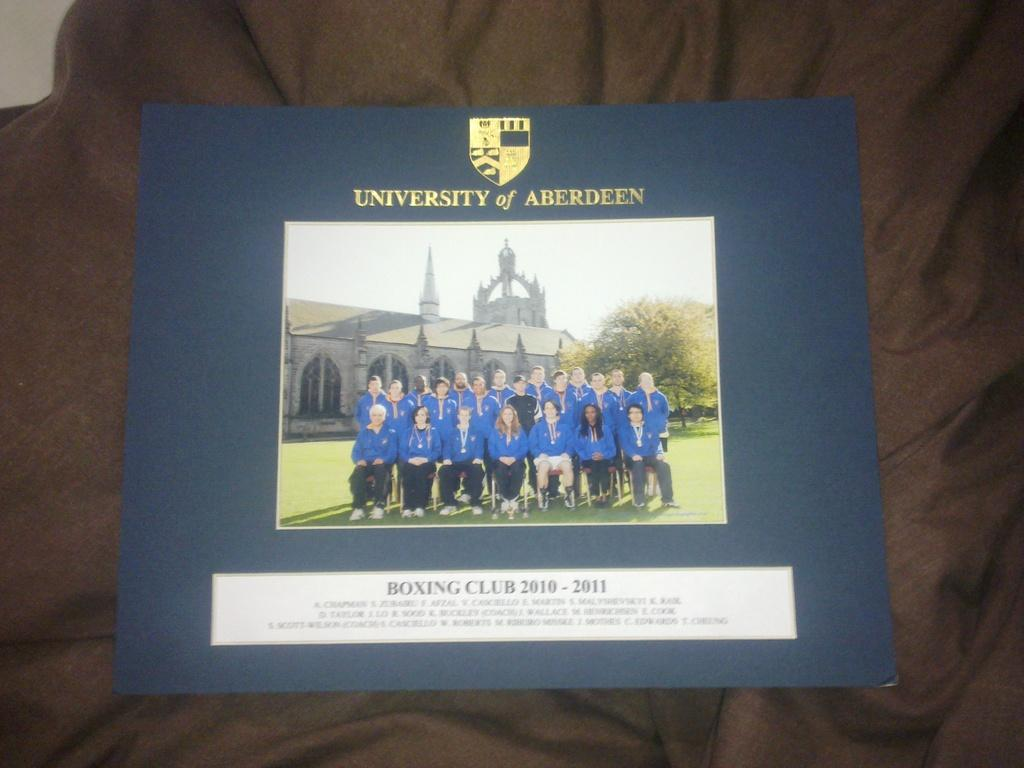<image>
Describe the image concisely. Above the photo on the blue background is the university of Aberdeen 